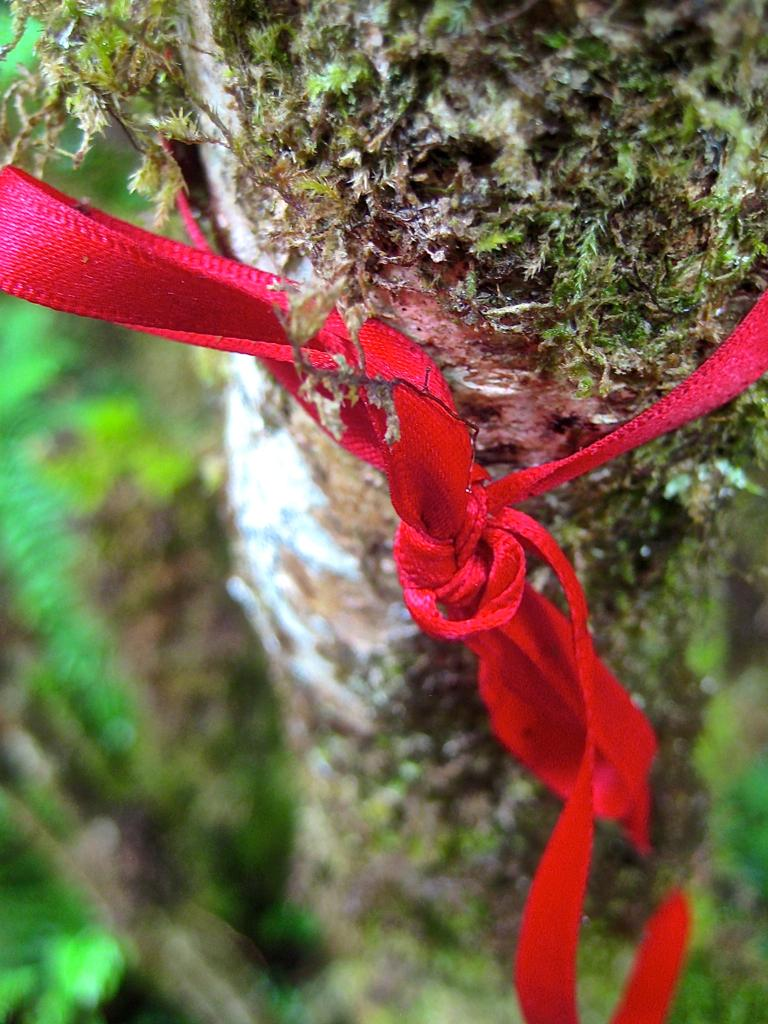What part of a tree can be seen in the image? The bark of a tree is visible in the image. Is there anything attached to the tree in the image? Yes, there is a rope tied to the tree in the image. What type of wing can be seen on the tree in the image? There are no wings present on the tree in the image. 